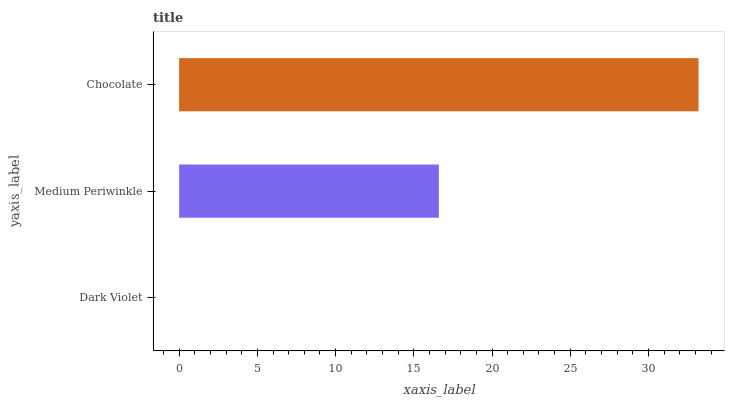Is Dark Violet the minimum?
Answer yes or no. Yes. Is Chocolate the maximum?
Answer yes or no. Yes. Is Medium Periwinkle the minimum?
Answer yes or no. No. Is Medium Periwinkle the maximum?
Answer yes or no. No. Is Medium Periwinkle greater than Dark Violet?
Answer yes or no. Yes. Is Dark Violet less than Medium Periwinkle?
Answer yes or no. Yes. Is Dark Violet greater than Medium Periwinkle?
Answer yes or no. No. Is Medium Periwinkle less than Dark Violet?
Answer yes or no. No. Is Medium Periwinkle the high median?
Answer yes or no. Yes. Is Medium Periwinkle the low median?
Answer yes or no. Yes. Is Dark Violet the high median?
Answer yes or no. No. Is Chocolate the low median?
Answer yes or no. No. 